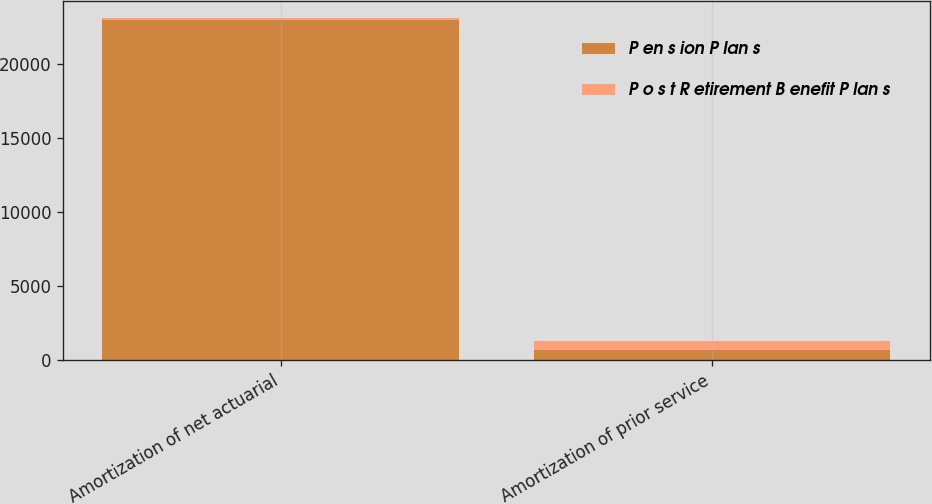Convert chart to OTSL. <chart><loc_0><loc_0><loc_500><loc_500><stacked_bar_chart><ecel><fcel>Amortization of net actuarial<fcel>Amortization of prior service<nl><fcel>P en s ion P lan s<fcel>22952<fcel>668<nl><fcel>P o s t R etirement B enefit P lan s<fcel>109<fcel>618<nl></chart> 